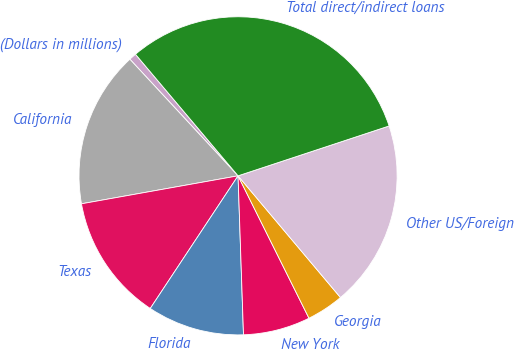<chart> <loc_0><loc_0><loc_500><loc_500><pie_chart><fcel>(Dollars in millions)<fcel>California<fcel>Texas<fcel>Florida<fcel>New York<fcel>Georgia<fcel>Other US/Foreign<fcel>Total direct/indirect loans<nl><fcel>0.75%<fcel>15.91%<fcel>12.88%<fcel>9.85%<fcel>6.81%<fcel>3.78%<fcel>18.94%<fcel>31.08%<nl></chart> 